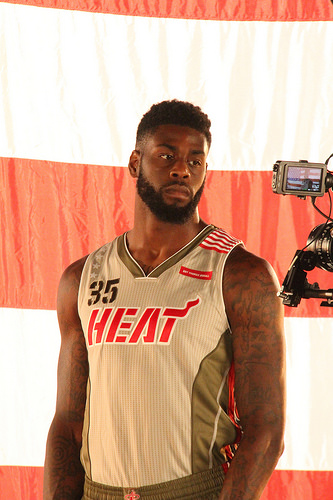<image>
Is the shirt next to the flag? No. The shirt is not positioned next to the flag. They are located in different areas of the scene. 